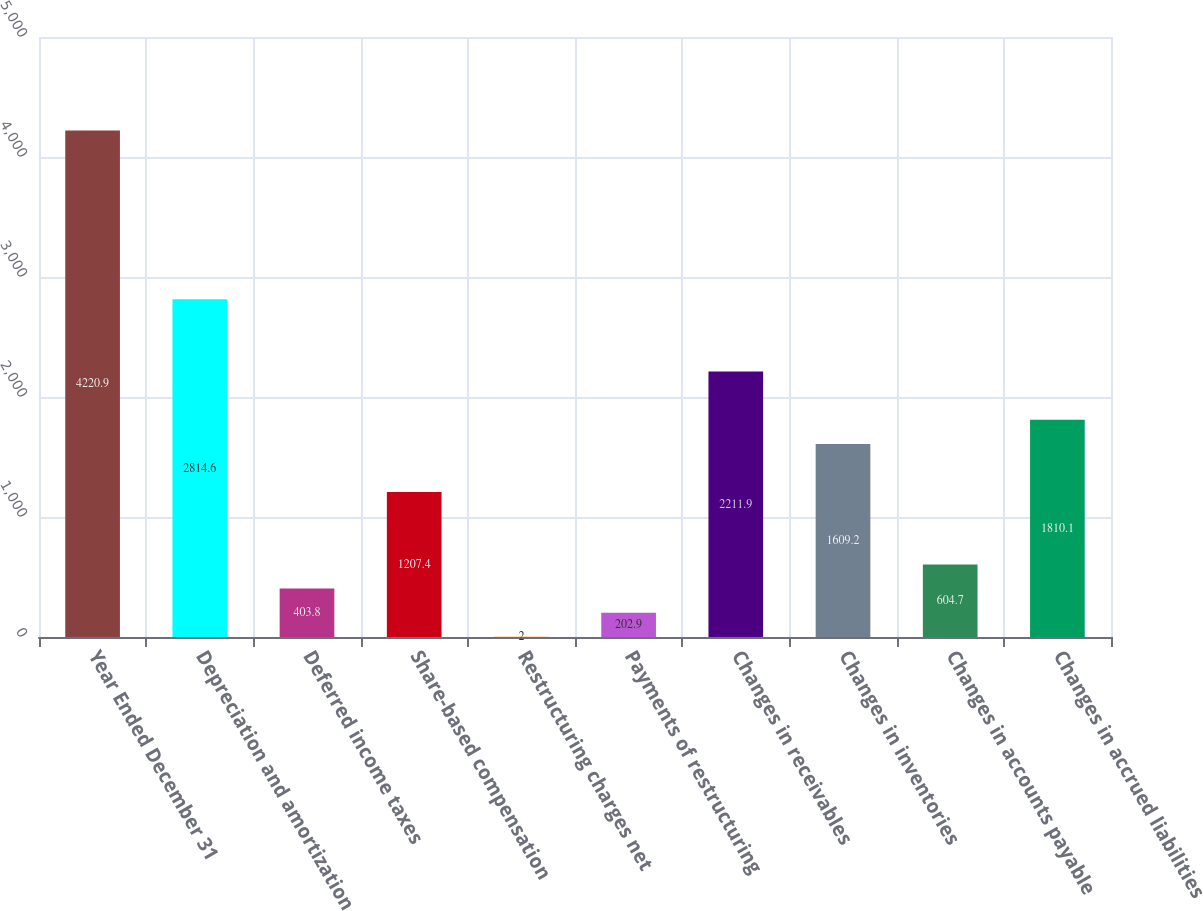Convert chart. <chart><loc_0><loc_0><loc_500><loc_500><bar_chart><fcel>Year Ended December 31<fcel>Depreciation and amortization<fcel>Deferred income taxes<fcel>Share-based compensation<fcel>Restructuring charges net<fcel>Payments of restructuring<fcel>Changes in receivables<fcel>Changes in inventories<fcel>Changes in accounts payable<fcel>Changes in accrued liabilities<nl><fcel>4220.9<fcel>2814.6<fcel>403.8<fcel>1207.4<fcel>2<fcel>202.9<fcel>2211.9<fcel>1609.2<fcel>604.7<fcel>1810.1<nl></chart> 